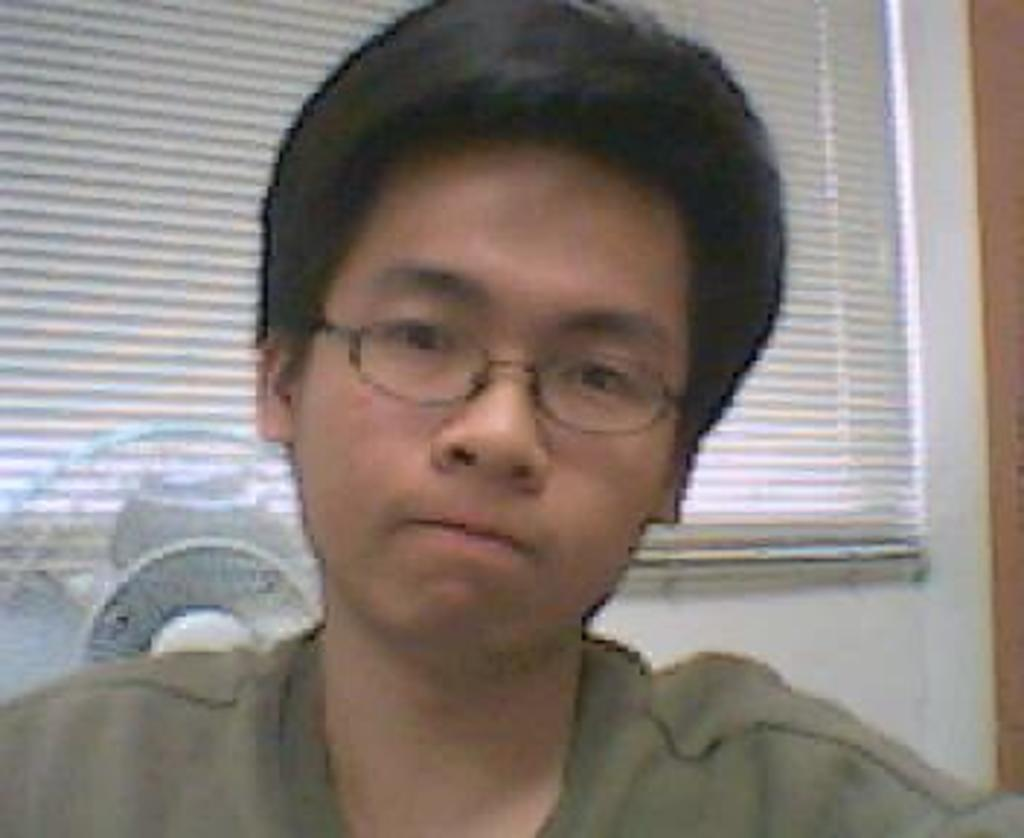Who is the main subject in the image? There is a man in the center of the image. What can be seen in the background of the image? There is a window, a wall, and a table fan in the background of the image. What type of liquid can be seen flowing from the tent in the image? There is no tent present in the image, so there is no liquid flowing from it. 